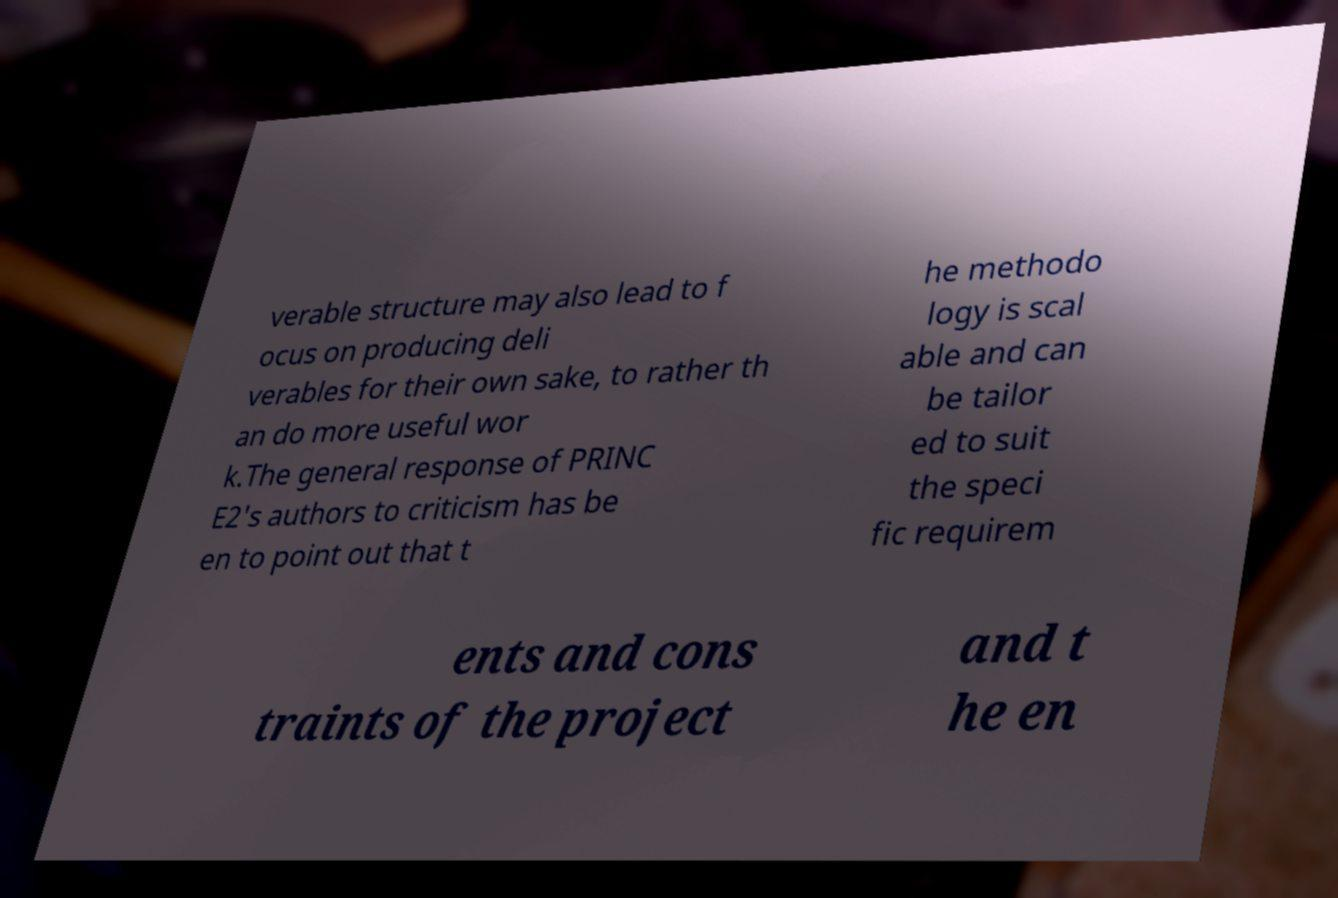I need the written content from this picture converted into text. Can you do that? verable structure may also lead to f ocus on producing deli verables for their own sake, to rather th an do more useful wor k.The general response of PRINC E2's authors to criticism has be en to point out that t he methodo logy is scal able and can be tailor ed to suit the speci fic requirem ents and cons traints of the project and t he en 